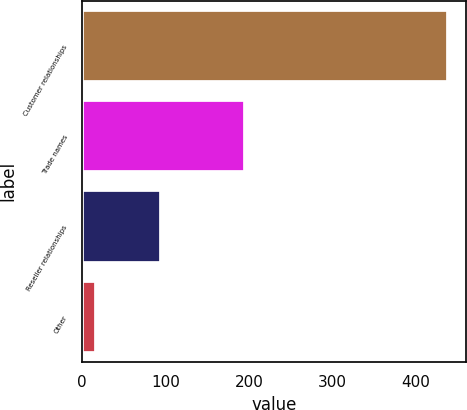Convert chart. <chart><loc_0><loc_0><loc_500><loc_500><bar_chart><fcel>Customer relationships<fcel>Trade names<fcel>Reseller relationships<fcel>Other<nl><fcel>438<fcel>195<fcel>95<fcel>17<nl></chart> 